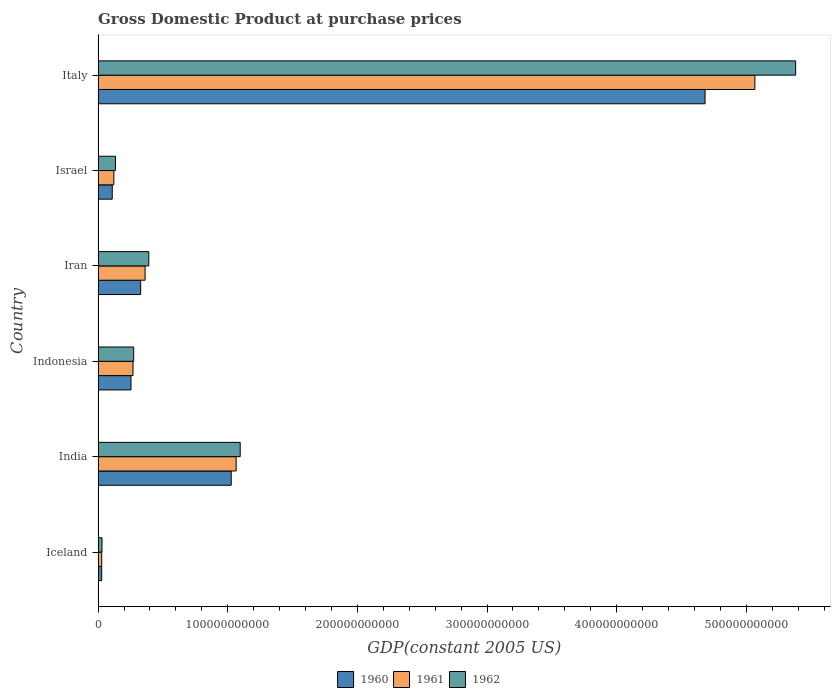Are the number of bars per tick equal to the number of legend labels?
Provide a short and direct response. Yes. Are the number of bars on each tick of the Y-axis equal?
Keep it short and to the point. Yes. How many bars are there on the 4th tick from the top?
Offer a very short reply. 3. How many bars are there on the 3rd tick from the bottom?
Provide a short and direct response. 3. In how many cases, is the number of bars for a given country not equal to the number of legend labels?
Give a very brief answer. 0. What is the GDP at purchase prices in 1962 in Israel?
Give a very brief answer. 1.34e+1. Across all countries, what is the maximum GDP at purchase prices in 1960?
Your answer should be compact. 4.68e+11. Across all countries, what is the minimum GDP at purchase prices in 1961?
Your answer should be very brief. 2.76e+09. What is the total GDP at purchase prices in 1960 in the graph?
Your response must be concise. 6.43e+11. What is the difference between the GDP at purchase prices in 1962 in India and that in Iran?
Your answer should be very brief. 7.05e+1. What is the difference between the GDP at purchase prices in 1961 in India and the GDP at purchase prices in 1960 in Indonesia?
Your answer should be compact. 8.11e+1. What is the average GDP at purchase prices in 1960 per country?
Provide a short and direct response. 1.07e+11. What is the difference between the GDP at purchase prices in 1961 and GDP at purchase prices in 1960 in Italy?
Keep it short and to the point. 3.84e+1. In how many countries, is the GDP at purchase prices in 1962 greater than 200000000000 US$?
Offer a very short reply. 1. What is the ratio of the GDP at purchase prices in 1960 in Israel to that in Italy?
Your answer should be very brief. 0.02. Is the GDP at purchase prices in 1961 in Indonesia less than that in Iran?
Offer a terse response. Yes. Is the difference between the GDP at purchase prices in 1961 in Iceland and Israel greater than the difference between the GDP at purchase prices in 1960 in Iceland and Israel?
Your answer should be very brief. No. What is the difference between the highest and the second highest GDP at purchase prices in 1962?
Provide a short and direct response. 4.28e+11. What is the difference between the highest and the lowest GDP at purchase prices in 1960?
Your response must be concise. 4.65e+11. Is the sum of the GDP at purchase prices in 1960 in Iceland and Iran greater than the maximum GDP at purchase prices in 1961 across all countries?
Give a very brief answer. No. Are all the bars in the graph horizontal?
Provide a short and direct response. Yes. What is the difference between two consecutive major ticks on the X-axis?
Your response must be concise. 1.00e+11. Does the graph contain grids?
Your answer should be compact. No. What is the title of the graph?
Your response must be concise. Gross Domestic Product at purchase prices. What is the label or title of the X-axis?
Ensure brevity in your answer.  GDP(constant 2005 US). What is the label or title of the Y-axis?
Ensure brevity in your answer.  Country. What is the GDP(constant 2005 US) in 1960 in Iceland?
Make the answer very short. 2.77e+09. What is the GDP(constant 2005 US) in 1961 in Iceland?
Your answer should be very brief. 2.76e+09. What is the GDP(constant 2005 US) of 1962 in Iceland?
Your response must be concise. 2.99e+09. What is the GDP(constant 2005 US) of 1960 in India?
Your response must be concise. 1.03e+11. What is the GDP(constant 2005 US) of 1961 in India?
Your answer should be very brief. 1.06e+11. What is the GDP(constant 2005 US) of 1962 in India?
Offer a very short reply. 1.10e+11. What is the GDP(constant 2005 US) of 1960 in Indonesia?
Make the answer very short. 2.54e+1. What is the GDP(constant 2005 US) in 1961 in Indonesia?
Offer a terse response. 2.69e+1. What is the GDP(constant 2005 US) of 1962 in Indonesia?
Ensure brevity in your answer.  2.74e+1. What is the GDP(constant 2005 US) of 1960 in Iran?
Provide a short and direct response. 3.28e+1. What is the GDP(constant 2005 US) of 1961 in Iran?
Ensure brevity in your answer.  3.62e+1. What is the GDP(constant 2005 US) in 1962 in Iran?
Offer a very short reply. 3.91e+1. What is the GDP(constant 2005 US) in 1960 in Israel?
Offer a very short reply. 1.09e+1. What is the GDP(constant 2005 US) of 1961 in Israel?
Make the answer very short. 1.21e+1. What is the GDP(constant 2005 US) of 1962 in Israel?
Provide a succinct answer. 1.34e+1. What is the GDP(constant 2005 US) in 1960 in Italy?
Ensure brevity in your answer.  4.68e+11. What is the GDP(constant 2005 US) in 1961 in Italy?
Ensure brevity in your answer.  5.07e+11. What is the GDP(constant 2005 US) in 1962 in Italy?
Provide a short and direct response. 5.38e+11. Across all countries, what is the maximum GDP(constant 2005 US) in 1960?
Your response must be concise. 4.68e+11. Across all countries, what is the maximum GDP(constant 2005 US) of 1961?
Provide a succinct answer. 5.07e+11. Across all countries, what is the maximum GDP(constant 2005 US) of 1962?
Your answer should be compact. 5.38e+11. Across all countries, what is the minimum GDP(constant 2005 US) of 1960?
Ensure brevity in your answer.  2.77e+09. Across all countries, what is the minimum GDP(constant 2005 US) in 1961?
Provide a short and direct response. 2.76e+09. Across all countries, what is the minimum GDP(constant 2005 US) in 1962?
Your response must be concise. 2.99e+09. What is the total GDP(constant 2005 US) of 1960 in the graph?
Provide a succinct answer. 6.43e+11. What is the total GDP(constant 2005 US) of 1961 in the graph?
Offer a terse response. 6.91e+11. What is the total GDP(constant 2005 US) in 1962 in the graph?
Offer a very short reply. 7.31e+11. What is the difference between the GDP(constant 2005 US) in 1960 in Iceland and that in India?
Ensure brevity in your answer.  -9.99e+1. What is the difference between the GDP(constant 2005 US) of 1961 in Iceland and that in India?
Ensure brevity in your answer.  -1.04e+11. What is the difference between the GDP(constant 2005 US) in 1962 in Iceland and that in India?
Make the answer very short. -1.07e+11. What is the difference between the GDP(constant 2005 US) in 1960 in Iceland and that in Indonesia?
Provide a short and direct response. -2.26e+1. What is the difference between the GDP(constant 2005 US) of 1961 in Iceland and that in Indonesia?
Provide a succinct answer. -2.42e+1. What is the difference between the GDP(constant 2005 US) in 1962 in Iceland and that in Indonesia?
Provide a short and direct response. -2.44e+1. What is the difference between the GDP(constant 2005 US) in 1960 in Iceland and that in Iran?
Give a very brief answer. -3.00e+1. What is the difference between the GDP(constant 2005 US) in 1961 in Iceland and that in Iran?
Make the answer very short. -3.35e+1. What is the difference between the GDP(constant 2005 US) in 1962 in Iceland and that in Iran?
Provide a short and direct response. -3.61e+1. What is the difference between the GDP(constant 2005 US) of 1960 in Iceland and that in Israel?
Your answer should be compact. -8.14e+09. What is the difference between the GDP(constant 2005 US) of 1961 in Iceland and that in Israel?
Your answer should be compact. -9.36e+09. What is the difference between the GDP(constant 2005 US) of 1962 in Iceland and that in Israel?
Provide a succinct answer. -1.04e+1. What is the difference between the GDP(constant 2005 US) of 1960 in Iceland and that in Italy?
Provide a short and direct response. -4.65e+11. What is the difference between the GDP(constant 2005 US) of 1961 in Iceland and that in Italy?
Offer a very short reply. -5.04e+11. What is the difference between the GDP(constant 2005 US) in 1962 in Iceland and that in Italy?
Offer a very short reply. -5.35e+11. What is the difference between the GDP(constant 2005 US) of 1960 in India and that in Indonesia?
Offer a terse response. 7.73e+1. What is the difference between the GDP(constant 2005 US) in 1961 in India and that in Indonesia?
Your response must be concise. 7.96e+1. What is the difference between the GDP(constant 2005 US) of 1962 in India and that in Indonesia?
Offer a terse response. 8.22e+1. What is the difference between the GDP(constant 2005 US) of 1960 in India and that in Iran?
Offer a terse response. 6.98e+1. What is the difference between the GDP(constant 2005 US) in 1961 in India and that in Iran?
Give a very brief answer. 7.03e+1. What is the difference between the GDP(constant 2005 US) in 1962 in India and that in Iran?
Your answer should be compact. 7.05e+1. What is the difference between the GDP(constant 2005 US) in 1960 in India and that in Israel?
Keep it short and to the point. 9.18e+1. What is the difference between the GDP(constant 2005 US) in 1961 in India and that in Israel?
Keep it short and to the point. 9.44e+1. What is the difference between the GDP(constant 2005 US) of 1962 in India and that in Israel?
Make the answer very short. 9.62e+1. What is the difference between the GDP(constant 2005 US) of 1960 in India and that in Italy?
Offer a terse response. -3.66e+11. What is the difference between the GDP(constant 2005 US) in 1961 in India and that in Italy?
Ensure brevity in your answer.  -4.00e+11. What is the difference between the GDP(constant 2005 US) in 1962 in India and that in Italy?
Make the answer very short. -4.28e+11. What is the difference between the GDP(constant 2005 US) in 1960 in Indonesia and that in Iran?
Your response must be concise. -7.45e+09. What is the difference between the GDP(constant 2005 US) in 1961 in Indonesia and that in Iran?
Make the answer very short. -9.31e+09. What is the difference between the GDP(constant 2005 US) in 1962 in Indonesia and that in Iran?
Ensure brevity in your answer.  -1.17e+1. What is the difference between the GDP(constant 2005 US) of 1960 in Indonesia and that in Israel?
Your answer should be very brief. 1.45e+1. What is the difference between the GDP(constant 2005 US) of 1961 in Indonesia and that in Israel?
Your answer should be very brief. 1.48e+1. What is the difference between the GDP(constant 2005 US) in 1962 in Indonesia and that in Israel?
Provide a succinct answer. 1.41e+1. What is the difference between the GDP(constant 2005 US) in 1960 in Indonesia and that in Italy?
Your answer should be very brief. -4.43e+11. What is the difference between the GDP(constant 2005 US) in 1961 in Indonesia and that in Italy?
Give a very brief answer. -4.80e+11. What is the difference between the GDP(constant 2005 US) in 1962 in Indonesia and that in Italy?
Ensure brevity in your answer.  -5.11e+11. What is the difference between the GDP(constant 2005 US) of 1960 in Iran and that in Israel?
Offer a very short reply. 2.19e+1. What is the difference between the GDP(constant 2005 US) of 1961 in Iran and that in Israel?
Ensure brevity in your answer.  2.41e+1. What is the difference between the GDP(constant 2005 US) in 1962 in Iran and that in Israel?
Offer a very short reply. 2.57e+1. What is the difference between the GDP(constant 2005 US) of 1960 in Iran and that in Italy?
Keep it short and to the point. -4.35e+11. What is the difference between the GDP(constant 2005 US) of 1961 in Iran and that in Italy?
Your answer should be compact. -4.70e+11. What is the difference between the GDP(constant 2005 US) of 1962 in Iran and that in Italy?
Provide a succinct answer. -4.99e+11. What is the difference between the GDP(constant 2005 US) in 1960 in Israel and that in Italy?
Make the answer very short. -4.57e+11. What is the difference between the GDP(constant 2005 US) in 1961 in Israel and that in Italy?
Give a very brief answer. -4.94e+11. What is the difference between the GDP(constant 2005 US) in 1962 in Israel and that in Italy?
Your answer should be compact. -5.25e+11. What is the difference between the GDP(constant 2005 US) of 1960 in Iceland and the GDP(constant 2005 US) of 1961 in India?
Your answer should be very brief. -1.04e+11. What is the difference between the GDP(constant 2005 US) of 1960 in Iceland and the GDP(constant 2005 US) of 1962 in India?
Your response must be concise. -1.07e+11. What is the difference between the GDP(constant 2005 US) of 1961 in Iceland and the GDP(constant 2005 US) of 1962 in India?
Your response must be concise. -1.07e+11. What is the difference between the GDP(constant 2005 US) of 1960 in Iceland and the GDP(constant 2005 US) of 1961 in Indonesia?
Give a very brief answer. -2.42e+1. What is the difference between the GDP(constant 2005 US) in 1960 in Iceland and the GDP(constant 2005 US) in 1962 in Indonesia?
Provide a short and direct response. -2.47e+1. What is the difference between the GDP(constant 2005 US) in 1961 in Iceland and the GDP(constant 2005 US) in 1962 in Indonesia?
Offer a terse response. -2.47e+1. What is the difference between the GDP(constant 2005 US) of 1960 in Iceland and the GDP(constant 2005 US) of 1961 in Iran?
Ensure brevity in your answer.  -3.35e+1. What is the difference between the GDP(constant 2005 US) of 1960 in Iceland and the GDP(constant 2005 US) of 1962 in Iran?
Your response must be concise. -3.63e+1. What is the difference between the GDP(constant 2005 US) of 1961 in Iceland and the GDP(constant 2005 US) of 1962 in Iran?
Your response must be concise. -3.63e+1. What is the difference between the GDP(constant 2005 US) of 1960 in Iceland and the GDP(constant 2005 US) of 1961 in Israel?
Your answer should be very brief. -9.36e+09. What is the difference between the GDP(constant 2005 US) of 1960 in Iceland and the GDP(constant 2005 US) of 1962 in Israel?
Keep it short and to the point. -1.06e+1. What is the difference between the GDP(constant 2005 US) in 1961 in Iceland and the GDP(constant 2005 US) in 1962 in Israel?
Ensure brevity in your answer.  -1.06e+1. What is the difference between the GDP(constant 2005 US) of 1960 in Iceland and the GDP(constant 2005 US) of 1961 in Italy?
Your answer should be very brief. -5.04e+11. What is the difference between the GDP(constant 2005 US) in 1960 in Iceland and the GDP(constant 2005 US) in 1962 in Italy?
Provide a short and direct response. -5.35e+11. What is the difference between the GDP(constant 2005 US) of 1961 in Iceland and the GDP(constant 2005 US) of 1962 in Italy?
Keep it short and to the point. -5.35e+11. What is the difference between the GDP(constant 2005 US) of 1960 in India and the GDP(constant 2005 US) of 1961 in Indonesia?
Make the answer very short. 7.57e+1. What is the difference between the GDP(constant 2005 US) of 1960 in India and the GDP(constant 2005 US) of 1962 in Indonesia?
Your answer should be very brief. 7.52e+1. What is the difference between the GDP(constant 2005 US) of 1961 in India and the GDP(constant 2005 US) of 1962 in Indonesia?
Your answer should be compact. 7.90e+1. What is the difference between the GDP(constant 2005 US) of 1960 in India and the GDP(constant 2005 US) of 1961 in Iran?
Your answer should be compact. 6.64e+1. What is the difference between the GDP(constant 2005 US) in 1960 in India and the GDP(constant 2005 US) in 1962 in Iran?
Keep it short and to the point. 6.36e+1. What is the difference between the GDP(constant 2005 US) of 1961 in India and the GDP(constant 2005 US) of 1962 in Iran?
Your response must be concise. 6.74e+1. What is the difference between the GDP(constant 2005 US) of 1960 in India and the GDP(constant 2005 US) of 1961 in Israel?
Give a very brief answer. 9.05e+1. What is the difference between the GDP(constant 2005 US) of 1960 in India and the GDP(constant 2005 US) of 1962 in Israel?
Make the answer very short. 8.93e+1. What is the difference between the GDP(constant 2005 US) in 1961 in India and the GDP(constant 2005 US) in 1962 in Israel?
Make the answer very short. 9.31e+1. What is the difference between the GDP(constant 2005 US) in 1960 in India and the GDP(constant 2005 US) in 1961 in Italy?
Provide a short and direct response. -4.04e+11. What is the difference between the GDP(constant 2005 US) in 1960 in India and the GDP(constant 2005 US) in 1962 in Italy?
Provide a succinct answer. -4.35e+11. What is the difference between the GDP(constant 2005 US) of 1961 in India and the GDP(constant 2005 US) of 1962 in Italy?
Ensure brevity in your answer.  -4.32e+11. What is the difference between the GDP(constant 2005 US) of 1960 in Indonesia and the GDP(constant 2005 US) of 1961 in Iran?
Keep it short and to the point. -1.09e+1. What is the difference between the GDP(constant 2005 US) in 1960 in Indonesia and the GDP(constant 2005 US) in 1962 in Iran?
Provide a succinct answer. -1.37e+1. What is the difference between the GDP(constant 2005 US) of 1961 in Indonesia and the GDP(constant 2005 US) of 1962 in Iran?
Keep it short and to the point. -1.22e+1. What is the difference between the GDP(constant 2005 US) in 1960 in Indonesia and the GDP(constant 2005 US) in 1961 in Israel?
Your answer should be compact. 1.32e+1. What is the difference between the GDP(constant 2005 US) of 1960 in Indonesia and the GDP(constant 2005 US) of 1962 in Israel?
Provide a succinct answer. 1.20e+1. What is the difference between the GDP(constant 2005 US) in 1961 in Indonesia and the GDP(constant 2005 US) in 1962 in Israel?
Offer a very short reply. 1.36e+1. What is the difference between the GDP(constant 2005 US) in 1960 in Indonesia and the GDP(constant 2005 US) in 1961 in Italy?
Your response must be concise. -4.81e+11. What is the difference between the GDP(constant 2005 US) in 1960 in Indonesia and the GDP(constant 2005 US) in 1962 in Italy?
Your response must be concise. -5.13e+11. What is the difference between the GDP(constant 2005 US) of 1961 in Indonesia and the GDP(constant 2005 US) of 1962 in Italy?
Make the answer very short. -5.11e+11. What is the difference between the GDP(constant 2005 US) of 1960 in Iran and the GDP(constant 2005 US) of 1961 in Israel?
Provide a short and direct response. 2.07e+1. What is the difference between the GDP(constant 2005 US) in 1960 in Iran and the GDP(constant 2005 US) in 1962 in Israel?
Your response must be concise. 1.95e+1. What is the difference between the GDP(constant 2005 US) in 1961 in Iran and the GDP(constant 2005 US) in 1962 in Israel?
Provide a succinct answer. 2.29e+1. What is the difference between the GDP(constant 2005 US) of 1960 in Iran and the GDP(constant 2005 US) of 1961 in Italy?
Ensure brevity in your answer.  -4.74e+11. What is the difference between the GDP(constant 2005 US) of 1960 in Iran and the GDP(constant 2005 US) of 1962 in Italy?
Make the answer very short. -5.05e+11. What is the difference between the GDP(constant 2005 US) in 1961 in Iran and the GDP(constant 2005 US) in 1962 in Italy?
Offer a terse response. -5.02e+11. What is the difference between the GDP(constant 2005 US) in 1960 in Israel and the GDP(constant 2005 US) in 1961 in Italy?
Keep it short and to the point. -4.96e+11. What is the difference between the GDP(constant 2005 US) in 1960 in Israel and the GDP(constant 2005 US) in 1962 in Italy?
Offer a very short reply. -5.27e+11. What is the difference between the GDP(constant 2005 US) in 1961 in Israel and the GDP(constant 2005 US) in 1962 in Italy?
Offer a very short reply. -5.26e+11. What is the average GDP(constant 2005 US) of 1960 per country?
Make the answer very short. 1.07e+11. What is the average GDP(constant 2005 US) of 1961 per country?
Offer a very short reply. 1.15e+11. What is the average GDP(constant 2005 US) of 1962 per country?
Your answer should be very brief. 1.22e+11. What is the difference between the GDP(constant 2005 US) of 1960 and GDP(constant 2005 US) of 1961 in Iceland?
Provide a short and direct response. 2.34e+06. What is the difference between the GDP(constant 2005 US) of 1960 and GDP(constant 2005 US) of 1962 in Iceland?
Give a very brief answer. -2.27e+08. What is the difference between the GDP(constant 2005 US) of 1961 and GDP(constant 2005 US) of 1962 in Iceland?
Make the answer very short. -2.30e+08. What is the difference between the GDP(constant 2005 US) in 1960 and GDP(constant 2005 US) in 1961 in India?
Make the answer very short. -3.82e+09. What is the difference between the GDP(constant 2005 US) in 1960 and GDP(constant 2005 US) in 1962 in India?
Provide a succinct answer. -6.94e+09. What is the difference between the GDP(constant 2005 US) of 1961 and GDP(constant 2005 US) of 1962 in India?
Ensure brevity in your answer.  -3.12e+09. What is the difference between the GDP(constant 2005 US) of 1960 and GDP(constant 2005 US) of 1961 in Indonesia?
Provide a succinct answer. -1.55e+09. What is the difference between the GDP(constant 2005 US) in 1960 and GDP(constant 2005 US) in 1962 in Indonesia?
Keep it short and to the point. -2.06e+09. What is the difference between the GDP(constant 2005 US) in 1961 and GDP(constant 2005 US) in 1962 in Indonesia?
Keep it short and to the point. -5.14e+08. What is the difference between the GDP(constant 2005 US) of 1960 and GDP(constant 2005 US) of 1961 in Iran?
Give a very brief answer. -3.41e+09. What is the difference between the GDP(constant 2005 US) in 1960 and GDP(constant 2005 US) in 1962 in Iran?
Give a very brief answer. -6.27e+09. What is the difference between the GDP(constant 2005 US) in 1961 and GDP(constant 2005 US) in 1962 in Iran?
Provide a short and direct response. -2.87e+09. What is the difference between the GDP(constant 2005 US) in 1960 and GDP(constant 2005 US) in 1961 in Israel?
Your answer should be very brief. -1.22e+09. What is the difference between the GDP(constant 2005 US) of 1960 and GDP(constant 2005 US) of 1962 in Israel?
Your answer should be compact. -2.45e+09. What is the difference between the GDP(constant 2005 US) in 1961 and GDP(constant 2005 US) in 1962 in Israel?
Offer a terse response. -1.23e+09. What is the difference between the GDP(constant 2005 US) in 1960 and GDP(constant 2005 US) in 1961 in Italy?
Make the answer very short. -3.84e+1. What is the difference between the GDP(constant 2005 US) in 1960 and GDP(constant 2005 US) in 1962 in Italy?
Your answer should be compact. -6.99e+1. What is the difference between the GDP(constant 2005 US) of 1961 and GDP(constant 2005 US) of 1962 in Italy?
Provide a succinct answer. -3.14e+1. What is the ratio of the GDP(constant 2005 US) of 1960 in Iceland to that in India?
Your answer should be compact. 0.03. What is the ratio of the GDP(constant 2005 US) in 1961 in Iceland to that in India?
Your answer should be compact. 0.03. What is the ratio of the GDP(constant 2005 US) in 1962 in Iceland to that in India?
Ensure brevity in your answer.  0.03. What is the ratio of the GDP(constant 2005 US) in 1960 in Iceland to that in Indonesia?
Offer a terse response. 0.11. What is the ratio of the GDP(constant 2005 US) in 1961 in Iceland to that in Indonesia?
Your answer should be compact. 0.1. What is the ratio of the GDP(constant 2005 US) of 1962 in Iceland to that in Indonesia?
Offer a terse response. 0.11. What is the ratio of the GDP(constant 2005 US) in 1960 in Iceland to that in Iran?
Give a very brief answer. 0.08. What is the ratio of the GDP(constant 2005 US) of 1961 in Iceland to that in Iran?
Offer a terse response. 0.08. What is the ratio of the GDP(constant 2005 US) in 1962 in Iceland to that in Iran?
Give a very brief answer. 0.08. What is the ratio of the GDP(constant 2005 US) in 1960 in Iceland to that in Israel?
Offer a terse response. 0.25. What is the ratio of the GDP(constant 2005 US) of 1961 in Iceland to that in Israel?
Offer a very short reply. 0.23. What is the ratio of the GDP(constant 2005 US) of 1962 in Iceland to that in Israel?
Keep it short and to the point. 0.22. What is the ratio of the GDP(constant 2005 US) of 1960 in Iceland to that in Italy?
Make the answer very short. 0.01. What is the ratio of the GDP(constant 2005 US) of 1961 in Iceland to that in Italy?
Offer a terse response. 0.01. What is the ratio of the GDP(constant 2005 US) in 1962 in Iceland to that in Italy?
Offer a very short reply. 0.01. What is the ratio of the GDP(constant 2005 US) of 1960 in India to that in Indonesia?
Make the answer very short. 4.05. What is the ratio of the GDP(constant 2005 US) in 1961 in India to that in Indonesia?
Ensure brevity in your answer.  3.96. What is the ratio of the GDP(constant 2005 US) in 1962 in India to that in Indonesia?
Provide a succinct answer. 4. What is the ratio of the GDP(constant 2005 US) of 1960 in India to that in Iran?
Keep it short and to the point. 3.13. What is the ratio of the GDP(constant 2005 US) of 1961 in India to that in Iran?
Provide a short and direct response. 2.94. What is the ratio of the GDP(constant 2005 US) of 1962 in India to that in Iran?
Ensure brevity in your answer.  2.8. What is the ratio of the GDP(constant 2005 US) of 1960 in India to that in Israel?
Your response must be concise. 9.41. What is the ratio of the GDP(constant 2005 US) in 1961 in India to that in Israel?
Your answer should be compact. 8.78. What is the ratio of the GDP(constant 2005 US) in 1962 in India to that in Israel?
Provide a succinct answer. 8.21. What is the ratio of the GDP(constant 2005 US) of 1960 in India to that in Italy?
Offer a very short reply. 0.22. What is the ratio of the GDP(constant 2005 US) in 1961 in India to that in Italy?
Offer a terse response. 0.21. What is the ratio of the GDP(constant 2005 US) of 1962 in India to that in Italy?
Ensure brevity in your answer.  0.2. What is the ratio of the GDP(constant 2005 US) in 1960 in Indonesia to that in Iran?
Provide a short and direct response. 0.77. What is the ratio of the GDP(constant 2005 US) in 1961 in Indonesia to that in Iran?
Give a very brief answer. 0.74. What is the ratio of the GDP(constant 2005 US) of 1962 in Indonesia to that in Iran?
Provide a short and direct response. 0.7. What is the ratio of the GDP(constant 2005 US) of 1960 in Indonesia to that in Israel?
Give a very brief answer. 2.33. What is the ratio of the GDP(constant 2005 US) in 1961 in Indonesia to that in Israel?
Keep it short and to the point. 2.22. What is the ratio of the GDP(constant 2005 US) of 1962 in Indonesia to that in Israel?
Offer a very short reply. 2.05. What is the ratio of the GDP(constant 2005 US) in 1960 in Indonesia to that in Italy?
Provide a short and direct response. 0.05. What is the ratio of the GDP(constant 2005 US) of 1961 in Indonesia to that in Italy?
Provide a short and direct response. 0.05. What is the ratio of the GDP(constant 2005 US) of 1962 in Indonesia to that in Italy?
Provide a short and direct response. 0.05. What is the ratio of the GDP(constant 2005 US) in 1960 in Iran to that in Israel?
Keep it short and to the point. 3.01. What is the ratio of the GDP(constant 2005 US) of 1961 in Iran to that in Israel?
Your response must be concise. 2.99. What is the ratio of the GDP(constant 2005 US) of 1962 in Iran to that in Israel?
Provide a succinct answer. 2.93. What is the ratio of the GDP(constant 2005 US) in 1960 in Iran to that in Italy?
Offer a terse response. 0.07. What is the ratio of the GDP(constant 2005 US) in 1961 in Iran to that in Italy?
Provide a succinct answer. 0.07. What is the ratio of the GDP(constant 2005 US) in 1962 in Iran to that in Italy?
Offer a terse response. 0.07. What is the ratio of the GDP(constant 2005 US) in 1960 in Israel to that in Italy?
Your response must be concise. 0.02. What is the ratio of the GDP(constant 2005 US) in 1961 in Israel to that in Italy?
Offer a very short reply. 0.02. What is the ratio of the GDP(constant 2005 US) of 1962 in Israel to that in Italy?
Offer a terse response. 0.02. What is the difference between the highest and the second highest GDP(constant 2005 US) in 1960?
Your response must be concise. 3.66e+11. What is the difference between the highest and the second highest GDP(constant 2005 US) of 1961?
Offer a terse response. 4.00e+11. What is the difference between the highest and the second highest GDP(constant 2005 US) of 1962?
Your response must be concise. 4.28e+11. What is the difference between the highest and the lowest GDP(constant 2005 US) in 1960?
Your response must be concise. 4.65e+11. What is the difference between the highest and the lowest GDP(constant 2005 US) of 1961?
Provide a succinct answer. 5.04e+11. What is the difference between the highest and the lowest GDP(constant 2005 US) in 1962?
Ensure brevity in your answer.  5.35e+11. 